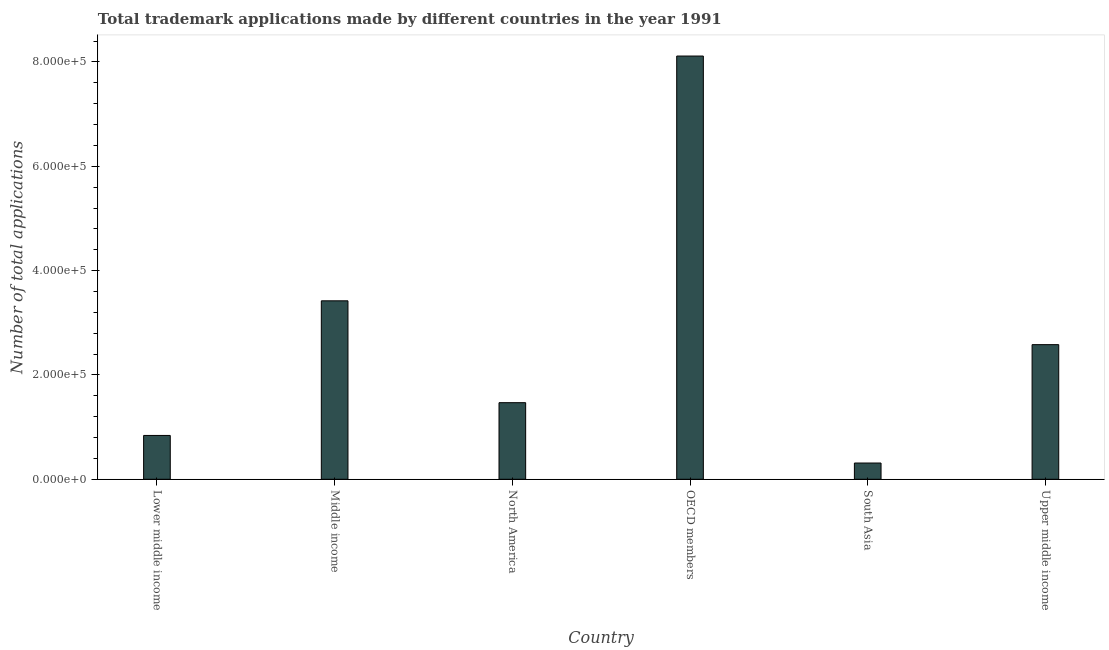Does the graph contain any zero values?
Make the answer very short. No. Does the graph contain grids?
Offer a very short reply. No. What is the title of the graph?
Ensure brevity in your answer.  Total trademark applications made by different countries in the year 1991. What is the label or title of the X-axis?
Offer a terse response. Country. What is the label or title of the Y-axis?
Your answer should be compact. Number of total applications. What is the number of trademark applications in Lower middle income?
Provide a short and direct response. 8.40e+04. Across all countries, what is the maximum number of trademark applications?
Give a very brief answer. 8.11e+05. Across all countries, what is the minimum number of trademark applications?
Ensure brevity in your answer.  3.11e+04. What is the sum of the number of trademark applications?
Keep it short and to the point. 1.67e+06. What is the difference between the number of trademark applications in Lower middle income and OECD members?
Your answer should be compact. -7.27e+05. What is the average number of trademark applications per country?
Provide a succinct answer. 2.79e+05. What is the median number of trademark applications?
Ensure brevity in your answer.  2.02e+05. In how many countries, is the number of trademark applications greater than 760000 ?
Ensure brevity in your answer.  1. What is the ratio of the number of trademark applications in North America to that in Upper middle income?
Keep it short and to the point. 0.57. Is the number of trademark applications in Middle income less than that in South Asia?
Keep it short and to the point. No. Is the difference between the number of trademark applications in Lower middle income and OECD members greater than the difference between any two countries?
Ensure brevity in your answer.  No. What is the difference between the highest and the second highest number of trademark applications?
Give a very brief answer. 4.69e+05. What is the difference between the highest and the lowest number of trademark applications?
Keep it short and to the point. 7.80e+05. In how many countries, is the number of trademark applications greater than the average number of trademark applications taken over all countries?
Make the answer very short. 2. How many bars are there?
Ensure brevity in your answer.  6. How many countries are there in the graph?
Offer a terse response. 6. Are the values on the major ticks of Y-axis written in scientific E-notation?
Offer a terse response. Yes. What is the Number of total applications of Lower middle income?
Your response must be concise. 8.40e+04. What is the Number of total applications in Middle income?
Provide a succinct answer. 3.42e+05. What is the Number of total applications of North America?
Provide a short and direct response. 1.47e+05. What is the Number of total applications of OECD members?
Your answer should be compact. 8.11e+05. What is the Number of total applications in South Asia?
Your answer should be compact. 3.11e+04. What is the Number of total applications in Upper middle income?
Make the answer very short. 2.58e+05. What is the difference between the Number of total applications in Lower middle income and Middle income?
Provide a short and direct response. -2.58e+05. What is the difference between the Number of total applications in Lower middle income and North America?
Offer a terse response. -6.28e+04. What is the difference between the Number of total applications in Lower middle income and OECD members?
Your answer should be compact. -7.27e+05. What is the difference between the Number of total applications in Lower middle income and South Asia?
Provide a short and direct response. 5.29e+04. What is the difference between the Number of total applications in Lower middle income and Upper middle income?
Provide a short and direct response. -1.74e+05. What is the difference between the Number of total applications in Middle income and North America?
Provide a succinct answer. 1.95e+05. What is the difference between the Number of total applications in Middle income and OECD members?
Offer a terse response. -4.69e+05. What is the difference between the Number of total applications in Middle income and South Asia?
Make the answer very short. 3.11e+05. What is the difference between the Number of total applications in Middle income and Upper middle income?
Offer a very short reply. 8.40e+04. What is the difference between the Number of total applications in North America and OECD members?
Your answer should be very brief. -6.64e+05. What is the difference between the Number of total applications in North America and South Asia?
Make the answer very short. 1.16e+05. What is the difference between the Number of total applications in North America and Upper middle income?
Your answer should be very brief. -1.11e+05. What is the difference between the Number of total applications in OECD members and South Asia?
Keep it short and to the point. 7.80e+05. What is the difference between the Number of total applications in OECD members and Upper middle income?
Ensure brevity in your answer.  5.53e+05. What is the difference between the Number of total applications in South Asia and Upper middle income?
Your response must be concise. -2.27e+05. What is the ratio of the Number of total applications in Lower middle income to that in Middle income?
Your response must be concise. 0.25. What is the ratio of the Number of total applications in Lower middle income to that in North America?
Provide a short and direct response. 0.57. What is the ratio of the Number of total applications in Lower middle income to that in OECD members?
Give a very brief answer. 0.1. What is the ratio of the Number of total applications in Lower middle income to that in South Asia?
Your response must be concise. 2.7. What is the ratio of the Number of total applications in Lower middle income to that in Upper middle income?
Provide a succinct answer. 0.33. What is the ratio of the Number of total applications in Middle income to that in North America?
Provide a short and direct response. 2.33. What is the ratio of the Number of total applications in Middle income to that in OECD members?
Give a very brief answer. 0.42. What is the ratio of the Number of total applications in Middle income to that in South Asia?
Your answer should be compact. 10.99. What is the ratio of the Number of total applications in Middle income to that in Upper middle income?
Your answer should be very brief. 1.33. What is the ratio of the Number of total applications in North America to that in OECD members?
Provide a short and direct response. 0.18. What is the ratio of the Number of total applications in North America to that in South Asia?
Provide a succinct answer. 4.72. What is the ratio of the Number of total applications in North America to that in Upper middle income?
Offer a terse response. 0.57. What is the ratio of the Number of total applications in OECD members to that in South Asia?
Provide a short and direct response. 26.06. What is the ratio of the Number of total applications in OECD members to that in Upper middle income?
Ensure brevity in your answer.  3.14. What is the ratio of the Number of total applications in South Asia to that in Upper middle income?
Offer a very short reply. 0.12. 